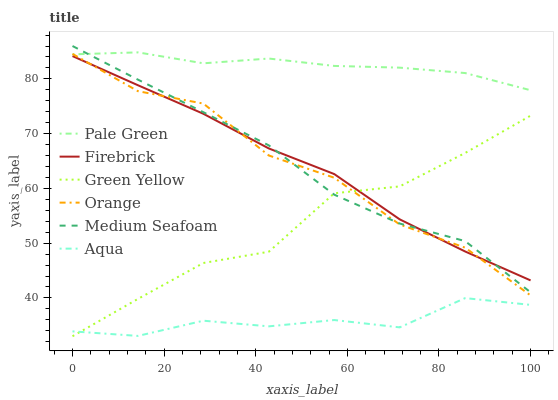Does Pale Green have the minimum area under the curve?
Answer yes or no. No. Does Aqua have the maximum area under the curve?
Answer yes or no. No. Is Aqua the smoothest?
Answer yes or no. No. Is Aqua the roughest?
Answer yes or no. No. Does Aqua have the lowest value?
Answer yes or no. No. Does Pale Green have the highest value?
Answer yes or no. No. Is Green Yellow less than Pale Green?
Answer yes or no. Yes. Is Pale Green greater than Aqua?
Answer yes or no. Yes. Does Green Yellow intersect Pale Green?
Answer yes or no. No. 